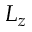Convert formula to latex. <formula><loc_0><loc_0><loc_500><loc_500>L _ { z }</formula> 